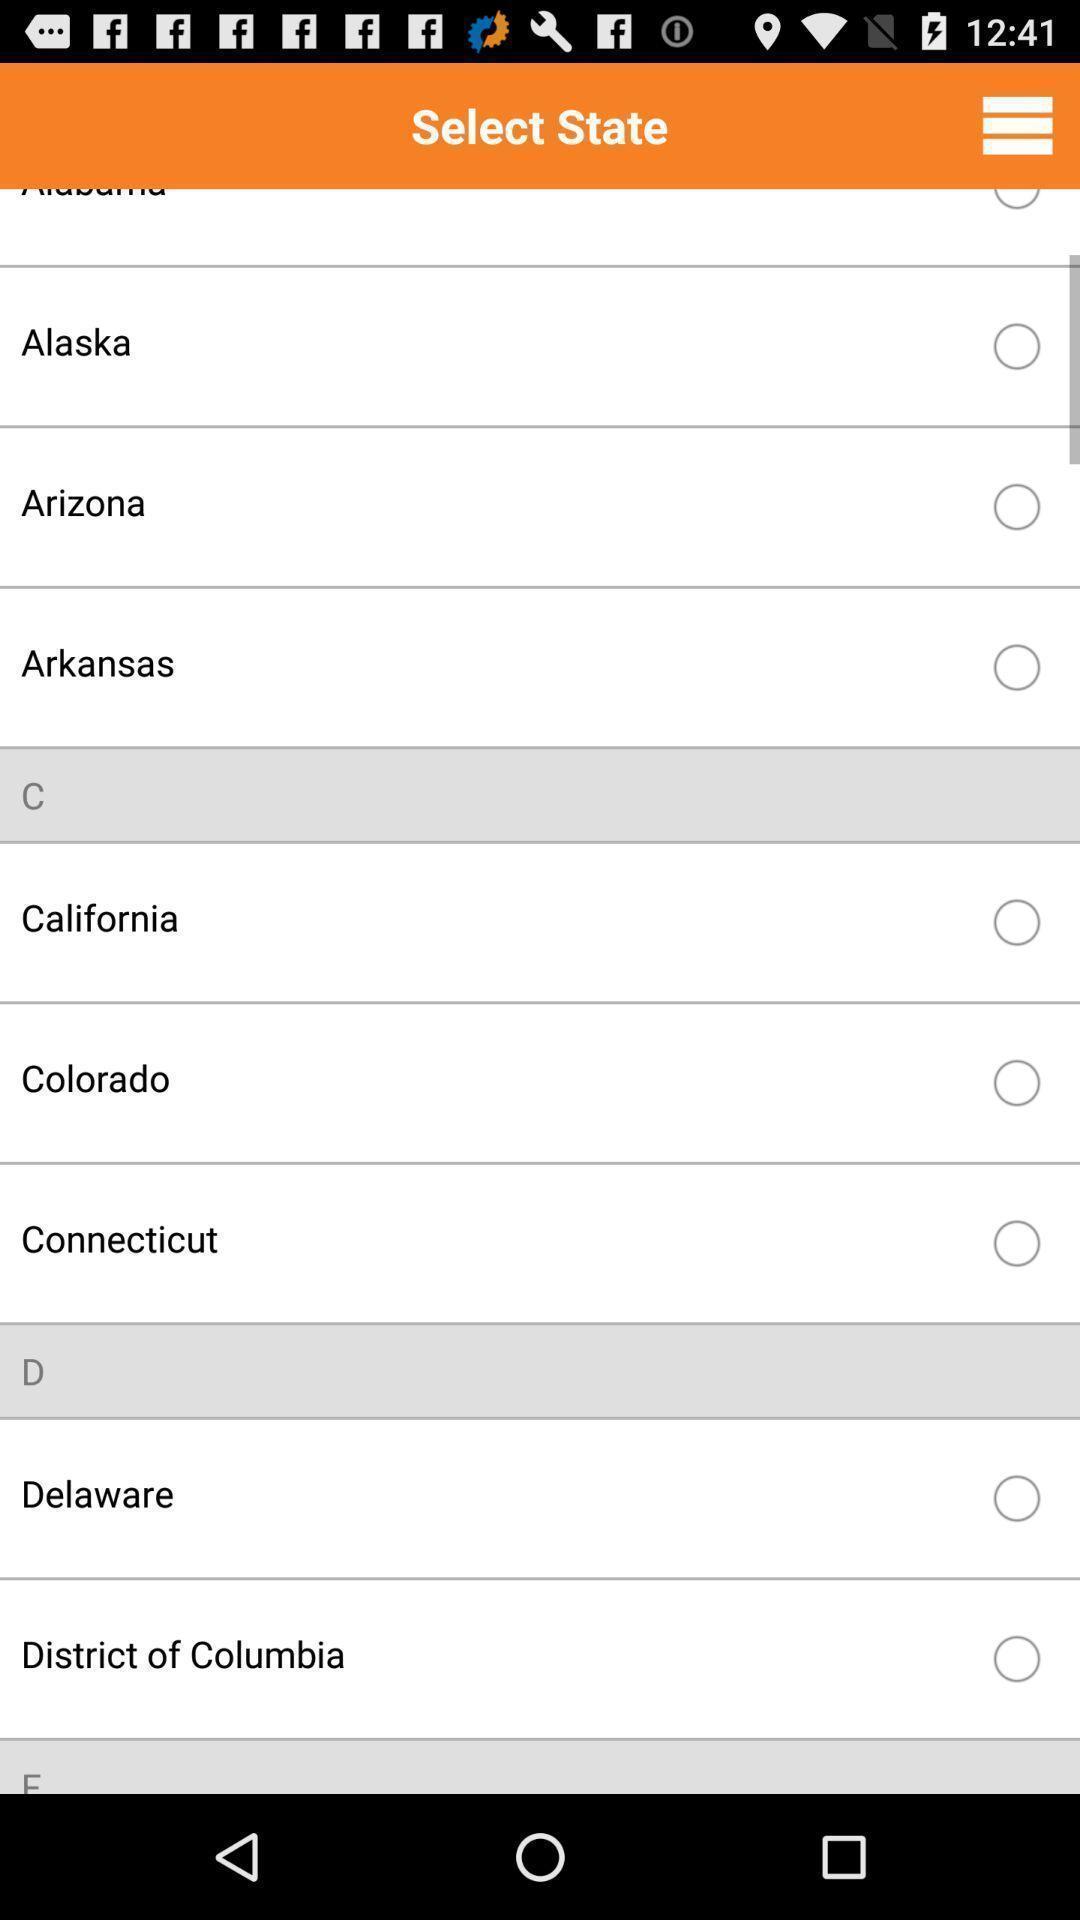Explain what's happening in this screen capture. State selection page of money saving app. 